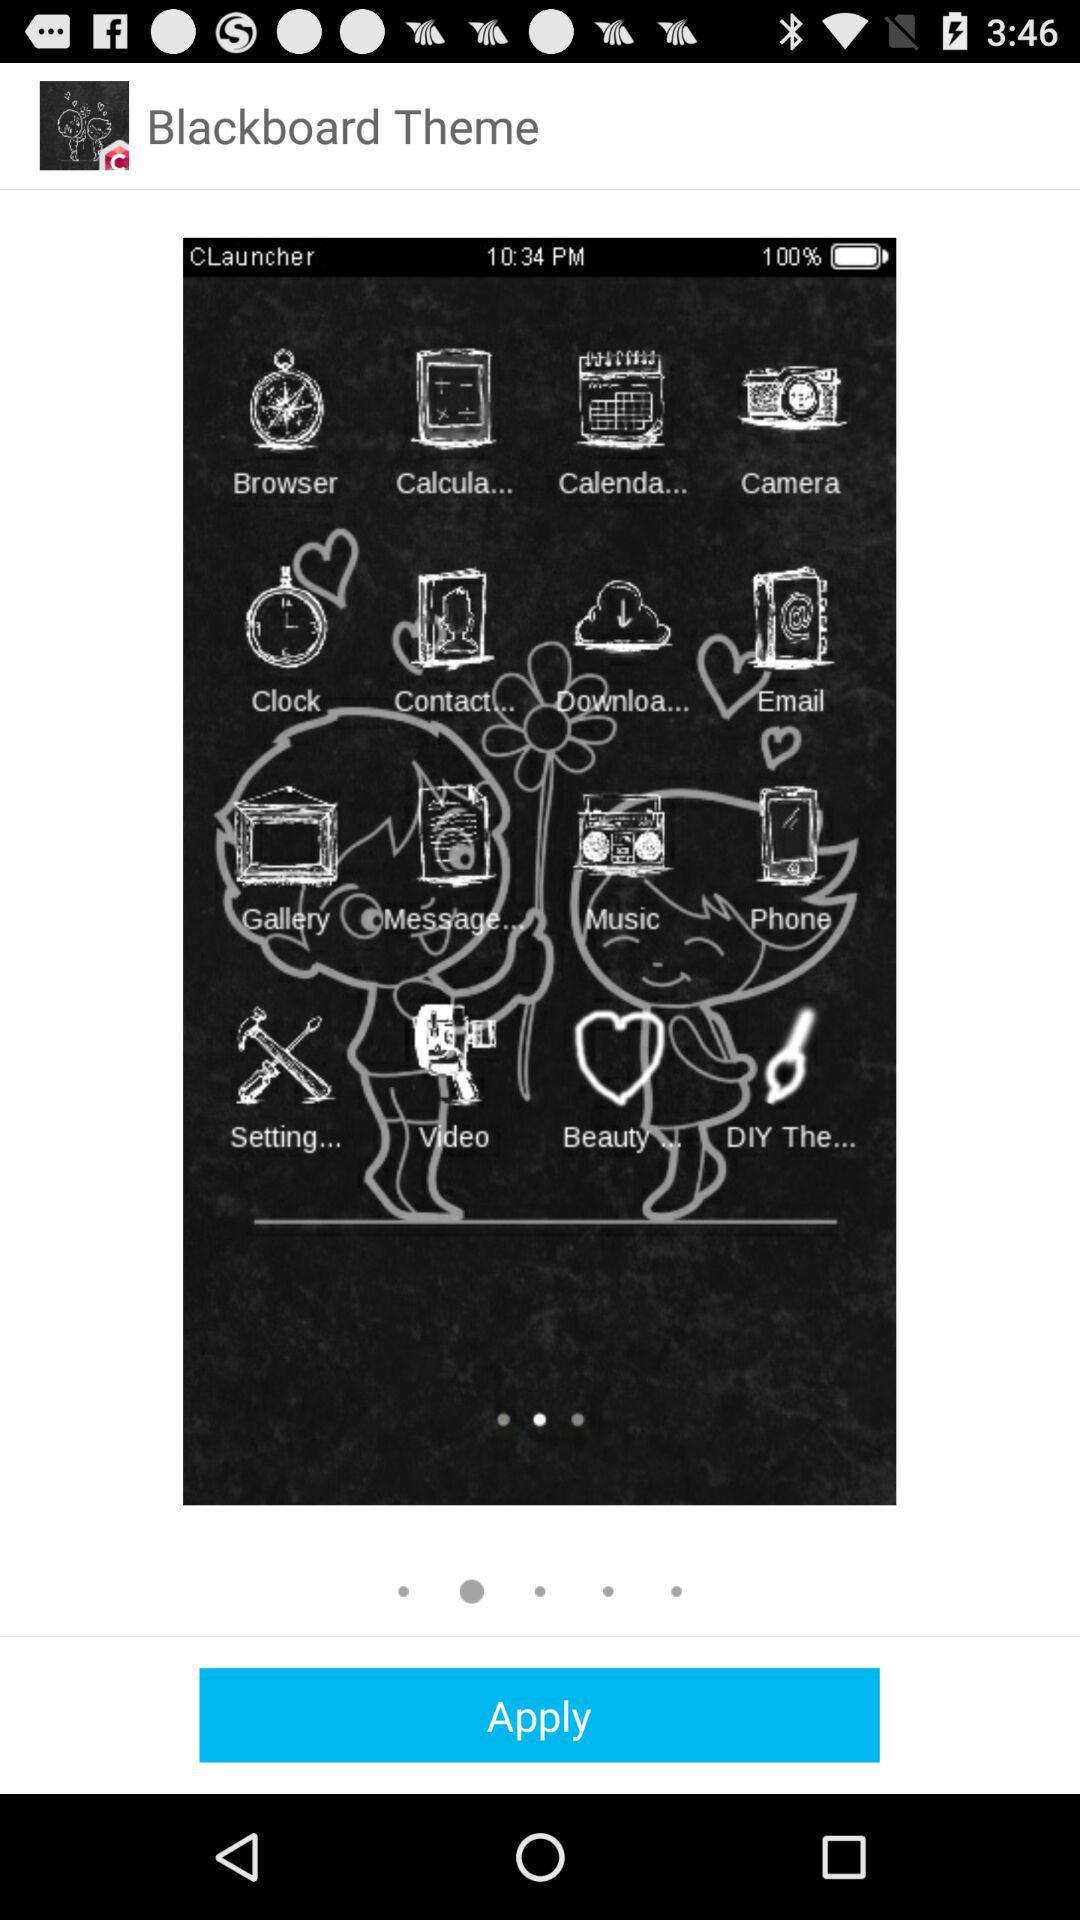How much does the theme cost?
When the provided information is insufficient, respond with <no answer>. <no answer> 